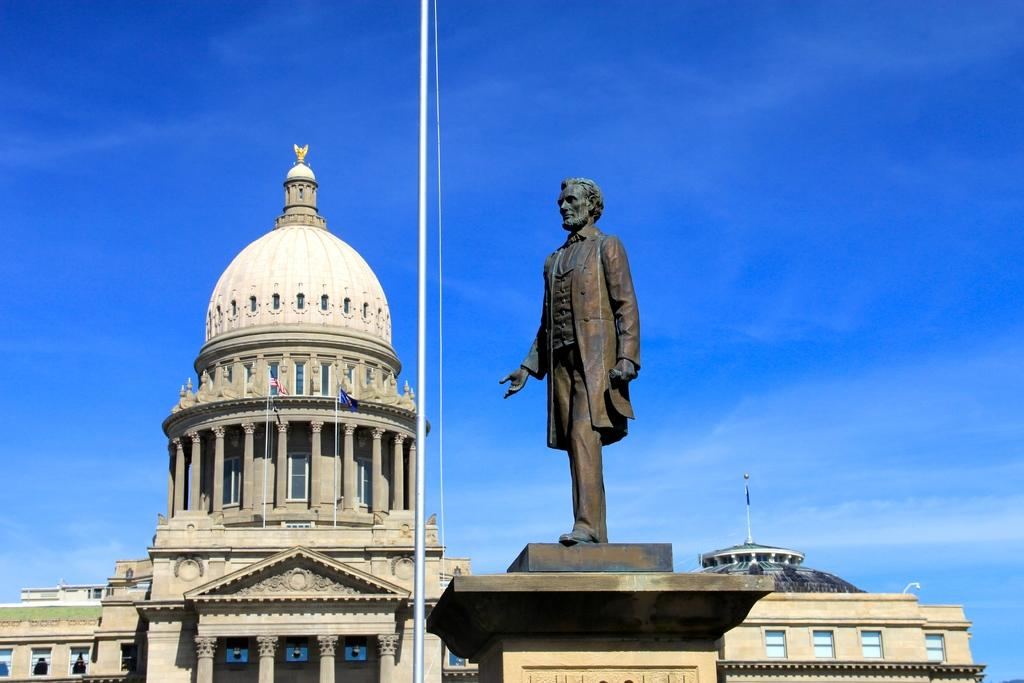What type of structure is present in the image? There is a building in the image. What other object can be seen in the image? There is a statue in the image. What part of the natural environment is visible in the image? The sky is visible in the image. What time of day is it in the image, and how does the statue feel about the morning? The time of day cannot be determined from the image, and there is no indication that the statue has feelings or emotions. 